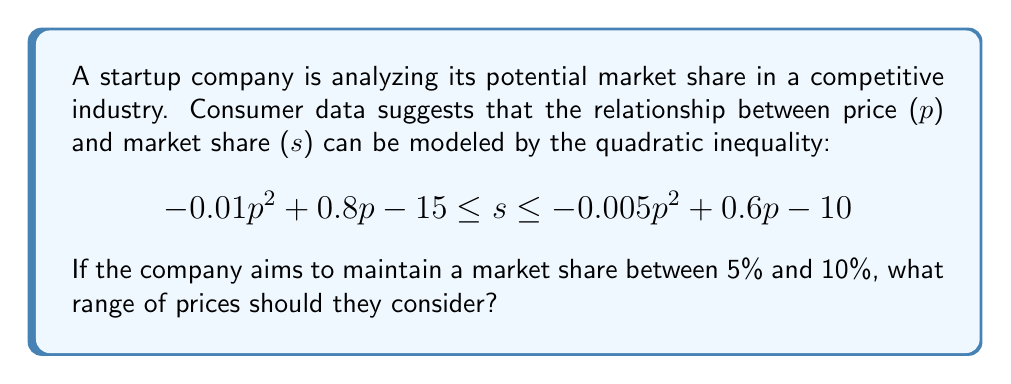Give your solution to this math problem. To solve this problem, we need to find the range of prices (p) that satisfy both inequalities simultaneously:

1) First, let's set up the inequalities:
   $$5 \leq -0.005p^2 + 0.6p - 10$$ (upper bound)
   $$-0.01p^2 + 0.8p - 15 \leq 10$$ (lower bound)

2) Solve the upper bound inequality:
   $$5 \leq -0.005p^2 + 0.6p - 10$$
   $$15 \leq -0.005p^2 + 0.6p$$
   $$0.005p^2 - 0.6p + 15 \leq 0$$
   $$p^2 - 120p + 3000 \leq 0$$
   $$(p - 30)(p - 90) \leq 0$$
   This is satisfied when $30 \leq p \leq 90$

3) Solve the lower bound inequality:
   $$-0.01p^2 + 0.8p - 15 \leq 10$$
   $$-0.01p^2 + 0.8p - 25 \leq 0$$
   $$p^2 - 80p + 2500 \geq 0$$
   $$(p - 50)(p - 30) \geq 0$$
   This is satisfied when $p \leq 30$ or $p \geq 50$

4) Combine the results:
   To satisfy both inequalities, we need $50 \leq p \leq 90$

Therefore, the company should consider prices between $50 and $90 to maintain a market share between 5% and 10%.
Answer: $50 \leq p \leq 90$ 